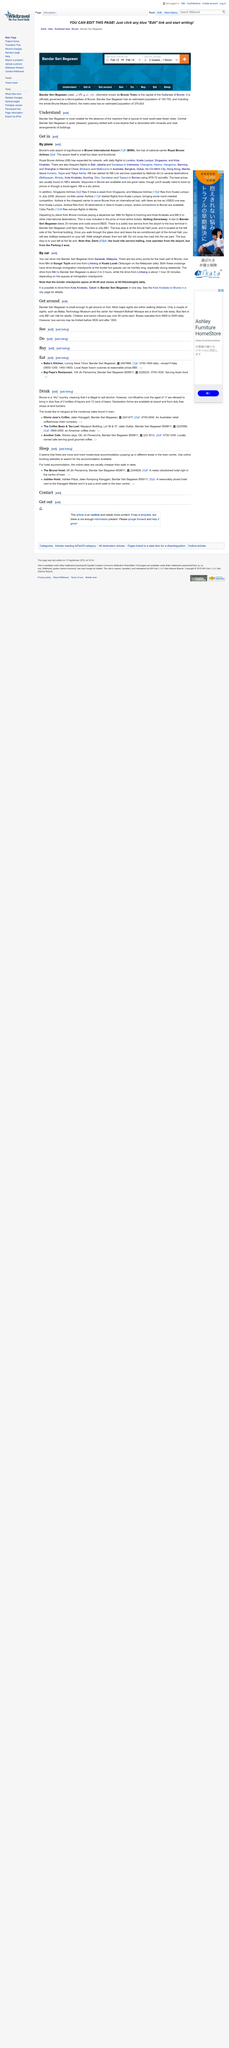Outline some significant characteristics in this image. The specific aircraft model used by RB for flights to destinations in Borneo is the ATR-72. According to the topic "Get around," seniors in Bandar Seri Begawan pay 50 cents each to use the bus. Royal Brunei Airlines is a well-known airline company that has been providing excellent service to its customers for many years. Many people associate the initials "RB" with this esteemed airline, and rightfully so. In order to reach the Malay Technology Museum and the Jame' Asr Hassanii Bolkiah Mosque, it would be necessary to take the bus to a specific location. The border checkpoint will close at midnight. 